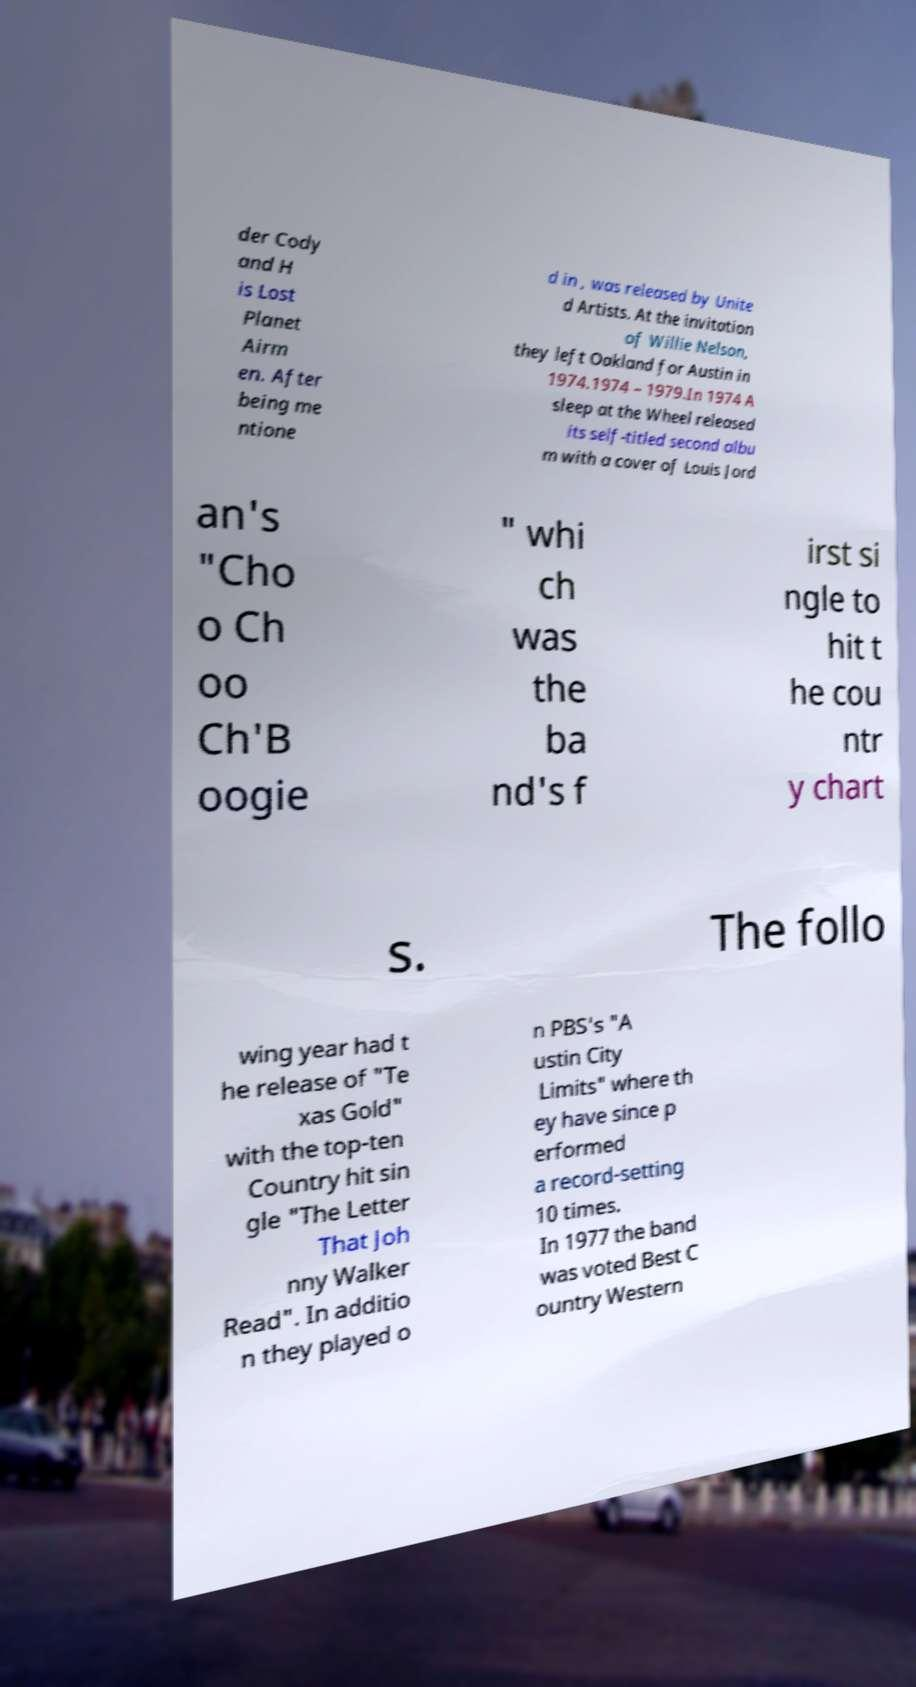Please identify and transcribe the text found in this image. der Cody and H is Lost Planet Airm en. After being me ntione d in , was released by Unite d Artists. At the invitation of Willie Nelson, they left Oakland for Austin in 1974.1974 – 1979.In 1974 A sleep at the Wheel released its self-titled second albu m with a cover of Louis Jord an's "Cho o Ch oo Ch'B oogie " whi ch was the ba nd's f irst si ngle to hit t he cou ntr y chart s. The follo wing year had t he release of "Te xas Gold" with the top-ten Country hit sin gle "The Letter That Joh nny Walker Read". In additio n they played o n PBS's "A ustin City Limits" where th ey have since p erformed a record-setting 10 times. In 1977 the band was voted Best C ountry Western 